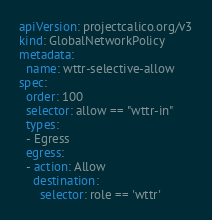<code> <loc_0><loc_0><loc_500><loc_500><_YAML_>apiVersion: projectcalico.org/v3
kind: GlobalNetworkPolicy
metadata:
  name: wttr-selective-allow
spec:
  order: 100
  selector: allow == "wttr-in"
  types:
  - Egress
  egress:
  - action: Allow
    destination:
      selector: role == 'wttr'
</code> 